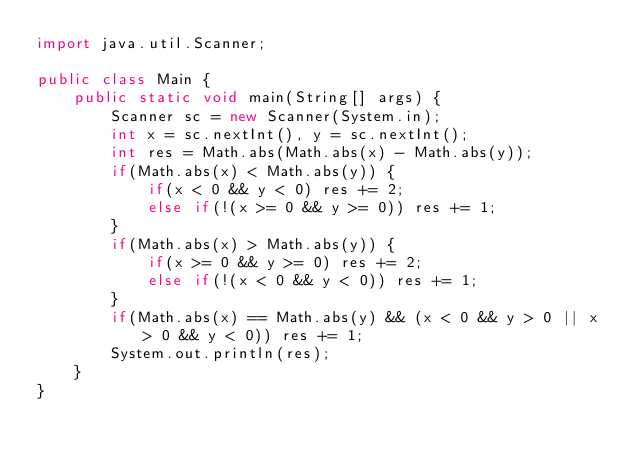<code> <loc_0><loc_0><loc_500><loc_500><_Java_>import java.util.Scanner;

public class Main {
    public static void main(String[] args) {
        Scanner sc = new Scanner(System.in);
        int x = sc.nextInt(), y = sc.nextInt();
        int res = Math.abs(Math.abs(x) - Math.abs(y));
        if(Math.abs(x) < Math.abs(y)) {
            if(x < 0 && y < 0) res += 2;
            else if(!(x >= 0 && y >= 0)) res += 1;
        }
        if(Math.abs(x) > Math.abs(y)) {
            if(x >= 0 && y >= 0) res += 2;
            else if(!(x < 0 && y < 0)) res += 1;
        }
        if(Math.abs(x) == Math.abs(y) && (x < 0 && y > 0 || x > 0 && y < 0)) res += 1;
        System.out.println(res);
    }
}
</code> 